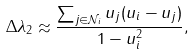Convert formula to latex. <formula><loc_0><loc_0><loc_500><loc_500>\Delta \lambda _ { 2 } \approx \frac { \sum _ { j \in { \mathcal { N } } _ { i } } u _ { j } ( u _ { i } - u _ { j } ) } { 1 - u _ { i } ^ { 2 } } ,</formula> 